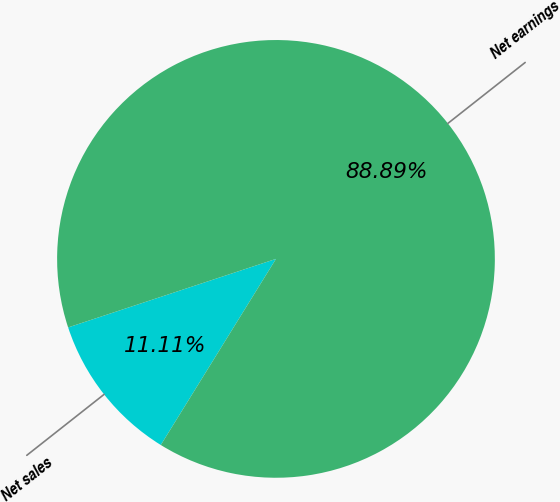Convert chart to OTSL. <chart><loc_0><loc_0><loc_500><loc_500><pie_chart><fcel>Net sales<fcel>Net earnings<nl><fcel>11.11%<fcel>88.89%<nl></chart> 